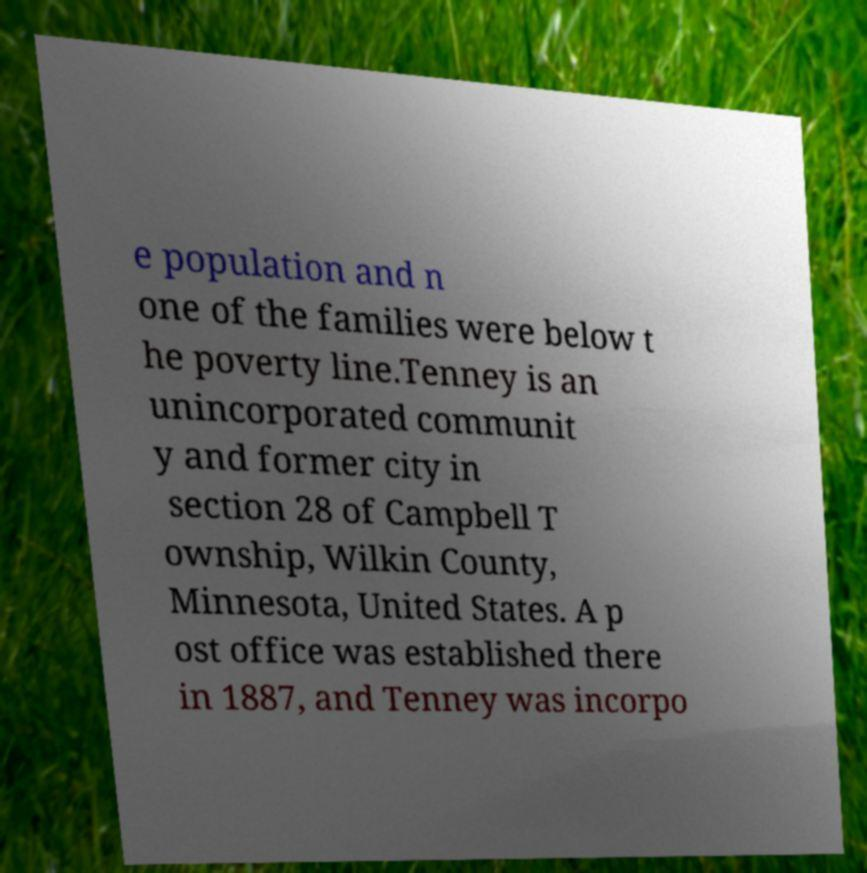Could you assist in decoding the text presented in this image and type it out clearly? e population and n one of the families were below t he poverty line.Tenney is an unincorporated communit y and former city in section 28 of Campbell T ownship, Wilkin County, Minnesota, United States. A p ost office was established there in 1887, and Tenney was incorpo 